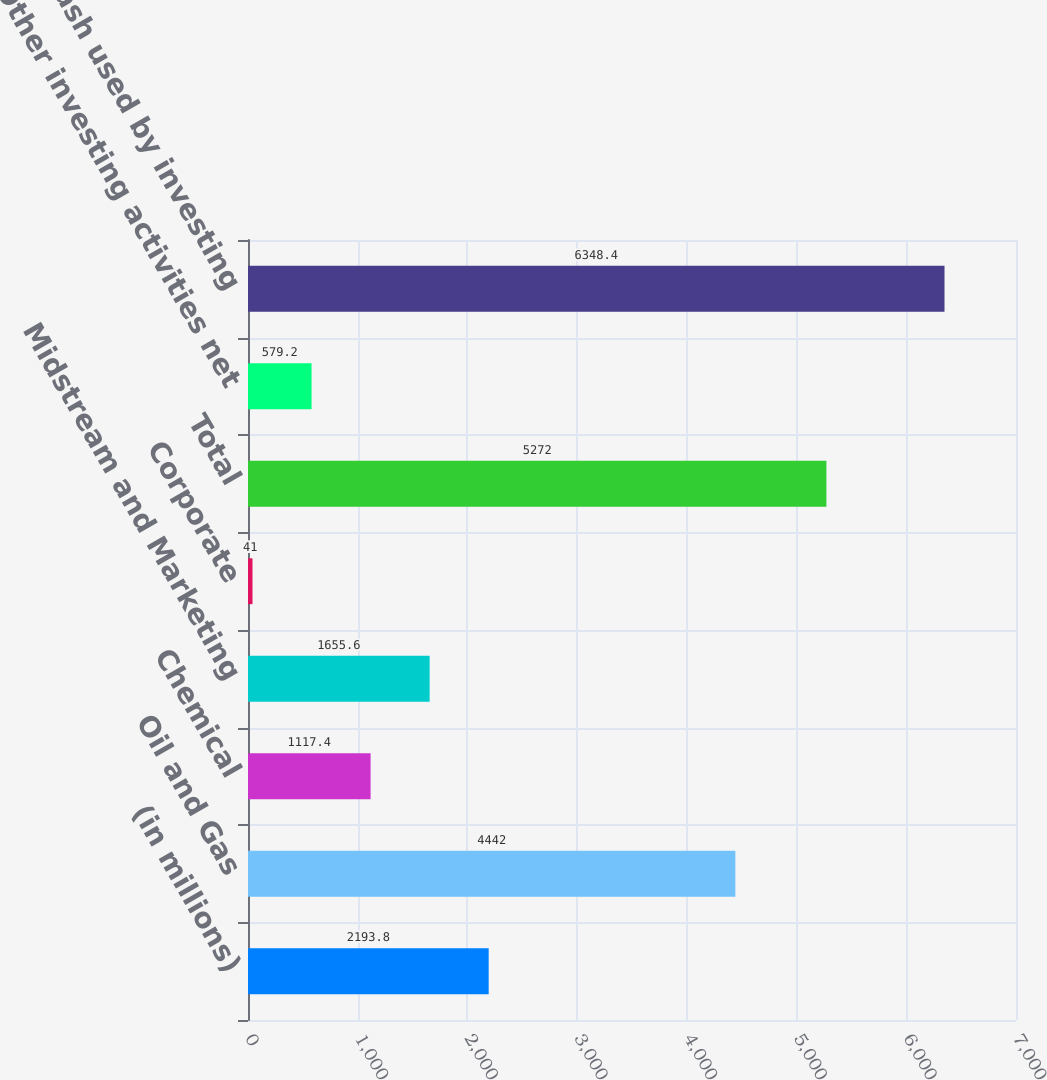<chart> <loc_0><loc_0><loc_500><loc_500><bar_chart><fcel>(in millions)<fcel>Oil and Gas<fcel>Chemical<fcel>Midstream and Marketing<fcel>Corporate<fcel>Total<fcel>Other investing activities net<fcel>Net cash used by investing<nl><fcel>2193.8<fcel>4442<fcel>1117.4<fcel>1655.6<fcel>41<fcel>5272<fcel>579.2<fcel>6348.4<nl></chart> 